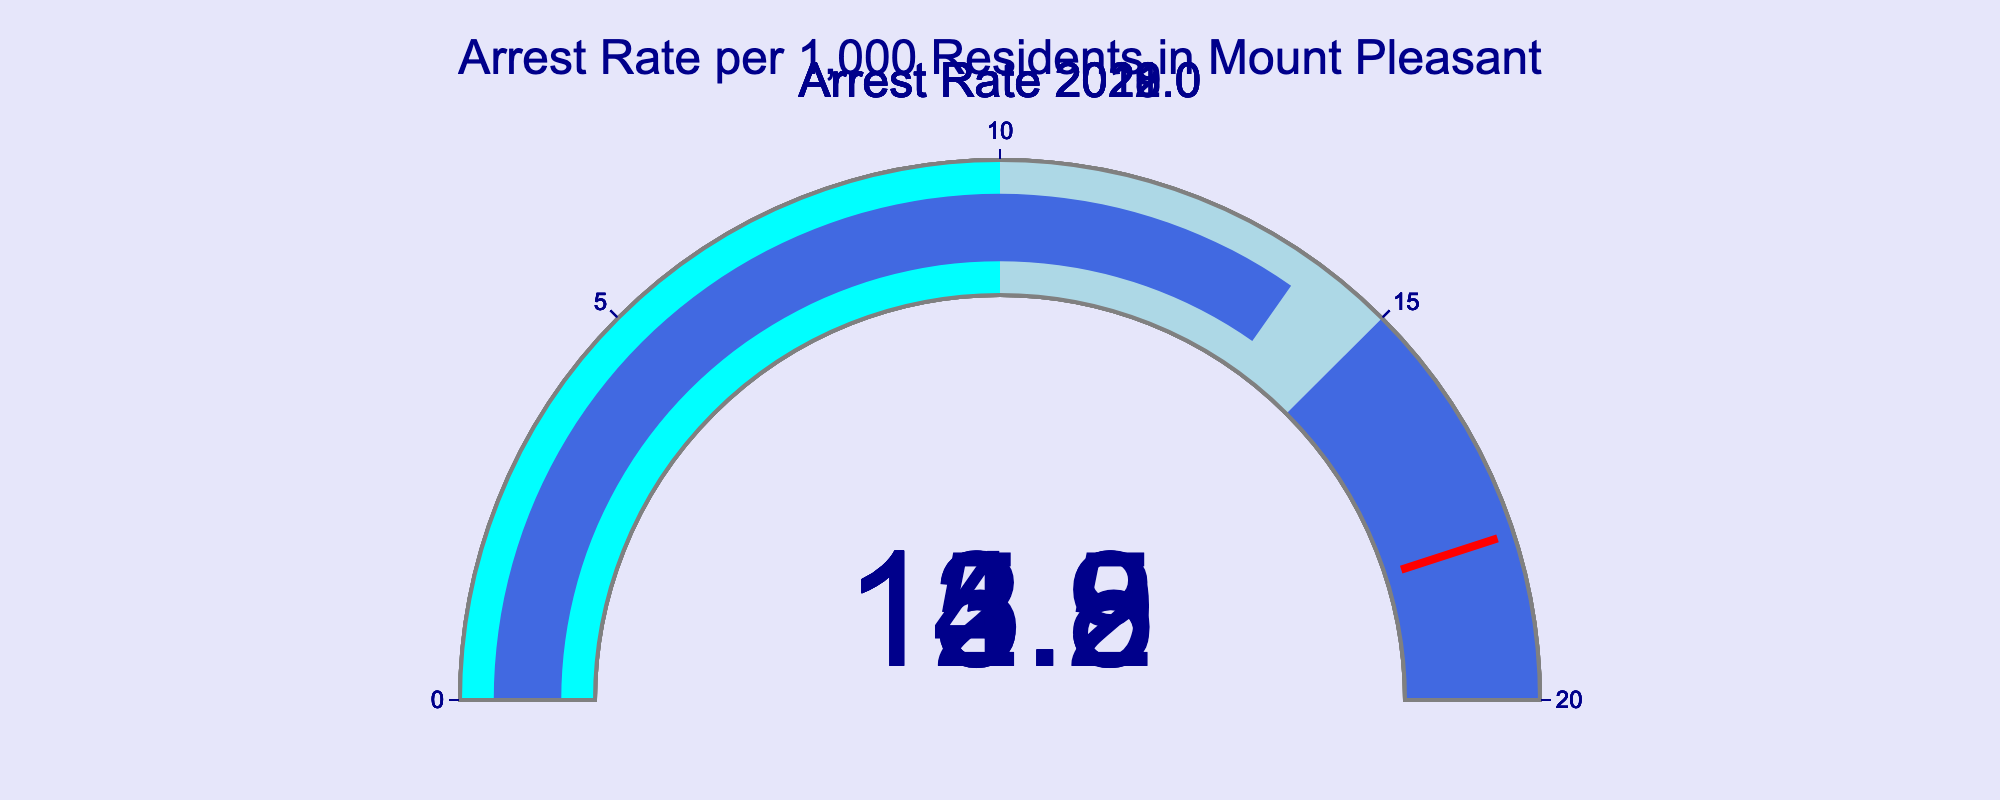What's the title of the figure? The title is displayed at the top center of the figure. It reads "Arrest Rate per 1,000 Residents in Mount Pleasant."
Answer: Arrest Rate per 1,000 Residents in Mount Pleasant What is the arrest rate for the year 2020? Look at the gauge associated with the year 2020. The number displayed is 15.2.
Answer: 15.2 What year had the highest arrest rate? Compare the values displayed on each gauge. The highest number is 15.2 in 2020.
Answer: 2020 Which year's arrest rate is closest to the average arrest rate over the displayed years? First, calculate the average arrest rate: (12.3 + 13.8 + 15.2 + 14.5 + 13.9) / 5 = 13.94. Then, compare each year's rate to this average. The year 2018 with a rate of 13.9 is the closest to the average.
Answer: 2018 Between 2019 and 2021, which year had a lower arrest rate? Compare the gauge values for the years 2019 and 2021. In 2019, the rate is 14.5, and in 2021, it is 13.8. 2021 has a lower rate.
Answer: 2021 What is the difference between the arrest rates for 2018 and 2022? Subtract the arrest rate for 2018 (13.9) from the arrest rate for 2022 (12.3). The difference is 1.6.
Answer: 1.6 How many years had an arrest rate above 14? Count the gauges with values above 14. The years 2019 and 2020 have arrest rates above 14, so there are 2 years in total.
Answer: 2 Is there any year where the arrest rate exceeded the top threshold value marked on the gauge? The top threshold value is marked at 18 on the gauge. None of the years showcased an arrest rate above 18.
Answer: No What's the general trend observed in the arrest rates from 2018 to 2022? Observing the values on each gauge from left to right: 2018 (13.9), 2019 (14.5), 2020 (15.2), 2021 (13.8), 2022 (12.3), the arrest rate appears to have a peak in 2020 and generally decreases afterwards.
Answer: Decreasing 